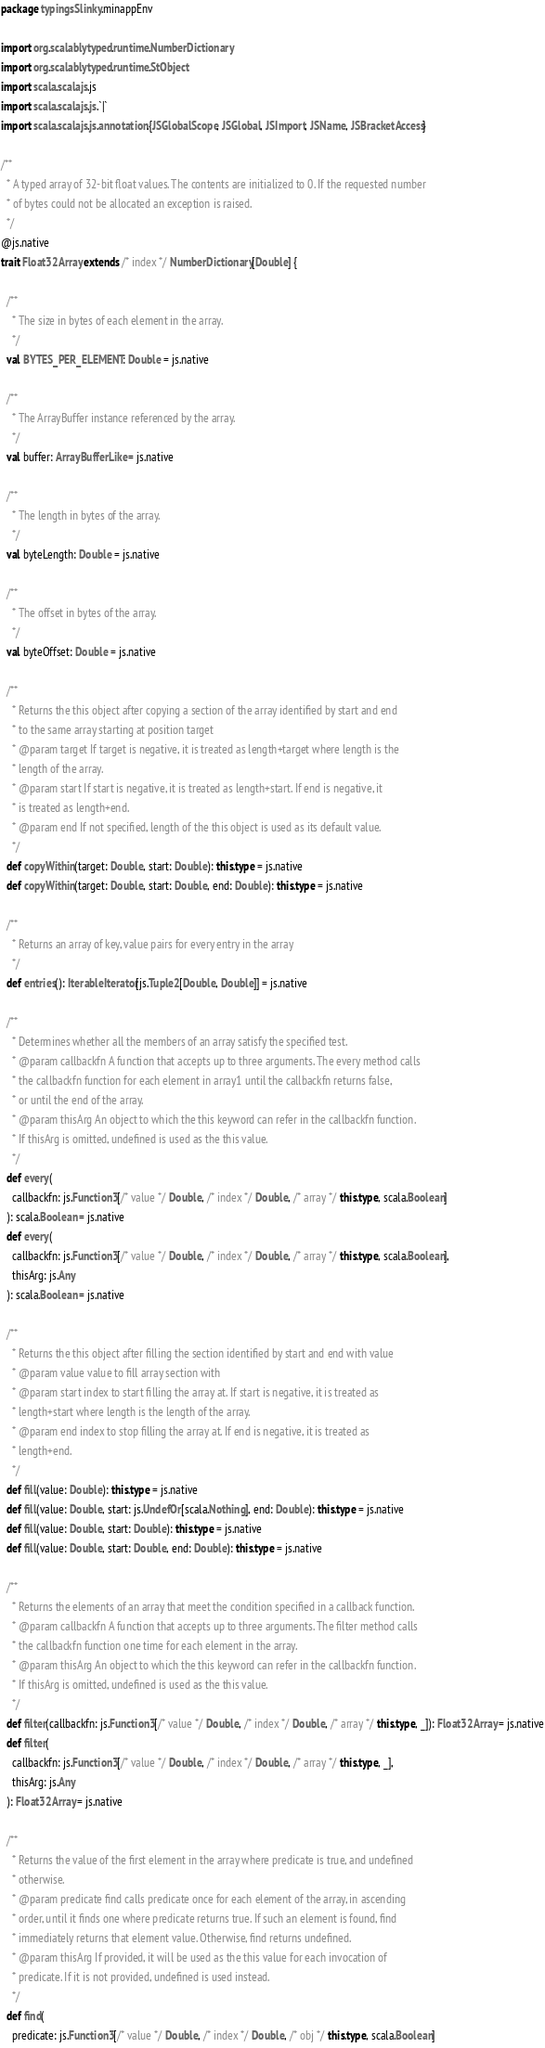Convert code to text. <code><loc_0><loc_0><loc_500><loc_500><_Scala_>package typingsSlinky.minappEnv

import org.scalablytyped.runtime.NumberDictionary
import org.scalablytyped.runtime.StObject
import scala.scalajs.js
import scala.scalajs.js.`|`
import scala.scalajs.js.annotation.{JSGlobalScope, JSGlobal, JSImport, JSName, JSBracketAccess}

/**
  * A typed array of 32-bit float values. The contents are initialized to 0. If the requested number
  * of bytes could not be allocated an exception is raised.
  */
@js.native
trait Float32Array extends /* index */ NumberDictionary[Double] {
  
  /**
    * The size in bytes of each element in the array.
    */
  val BYTES_PER_ELEMENT: Double = js.native
  
  /**
    * The ArrayBuffer instance referenced by the array.
    */
  val buffer: ArrayBufferLike = js.native
  
  /**
    * The length in bytes of the array.
    */
  val byteLength: Double = js.native
  
  /**
    * The offset in bytes of the array.
    */
  val byteOffset: Double = js.native
  
  /**
    * Returns the this object after copying a section of the array identified by start and end
    * to the same array starting at position target
    * @param target If target is negative, it is treated as length+target where length is the
    * length of the array.
    * @param start If start is negative, it is treated as length+start. If end is negative, it
    * is treated as length+end.
    * @param end If not specified, length of the this object is used as its default value.
    */
  def copyWithin(target: Double, start: Double): this.type = js.native
  def copyWithin(target: Double, start: Double, end: Double): this.type = js.native
  
  /**
    * Returns an array of key, value pairs for every entry in the array
    */
  def entries(): IterableIterator[js.Tuple2[Double, Double]] = js.native
  
  /**
    * Determines whether all the members of an array satisfy the specified test.
    * @param callbackfn A function that accepts up to three arguments. The every method calls
    * the callbackfn function for each element in array1 until the callbackfn returns false,
    * or until the end of the array.
    * @param thisArg An object to which the this keyword can refer in the callbackfn function.
    * If thisArg is omitted, undefined is used as the this value.
    */
  def every(
    callbackfn: js.Function3[/* value */ Double, /* index */ Double, /* array */ this.type, scala.Boolean]
  ): scala.Boolean = js.native
  def every(
    callbackfn: js.Function3[/* value */ Double, /* index */ Double, /* array */ this.type, scala.Boolean],
    thisArg: js.Any
  ): scala.Boolean = js.native
  
  /**
    * Returns the this object after filling the section identified by start and end with value
    * @param value value to fill array section with
    * @param start index to start filling the array at. If start is negative, it is treated as
    * length+start where length is the length of the array.
    * @param end index to stop filling the array at. If end is negative, it is treated as
    * length+end.
    */
  def fill(value: Double): this.type = js.native
  def fill(value: Double, start: js.UndefOr[scala.Nothing], end: Double): this.type = js.native
  def fill(value: Double, start: Double): this.type = js.native
  def fill(value: Double, start: Double, end: Double): this.type = js.native
  
  /**
    * Returns the elements of an array that meet the condition specified in a callback function.
    * @param callbackfn A function that accepts up to three arguments. The filter method calls
    * the callbackfn function one time for each element in the array.
    * @param thisArg An object to which the this keyword can refer in the callbackfn function.
    * If thisArg is omitted, undefined is used as the this value.
    */
  def filter(callbackfn: js.Function3[/* value */ Double, /* index */ Double, /* array */ this.type, _]): Float32Array = js.native
  def filter(
    callbackfn: js.Function3[/* value */ Double, /* index */ Double, /* array */ this.type, _],
    thisArg: js.Any
  ): Float32Array = js.native
  
  /**
    * Returns the value of the first element in the array where predicate is true, and undefined
    * otherwise.
    * @param predicate find calls predicate once for each element of the array, in ascending
    * order, until it finds one where predicate returns true. If such an element is found, find
    * immediately returns that element value. Otherwise, find returns undefined.
    * @param thisArg If provided, it will be used as the this value for each invocation of
    * predicate. If it is not provided, undefined is used instead.
    */
  def find(
    predicate: js.Function3[/* value */ Double, /* index */ Double, /* obj */ this.type, scala.Boolean]</code> 